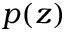<formula> <loc_0><loc_0><loc_500><loc_500>p ( z )</formula> 